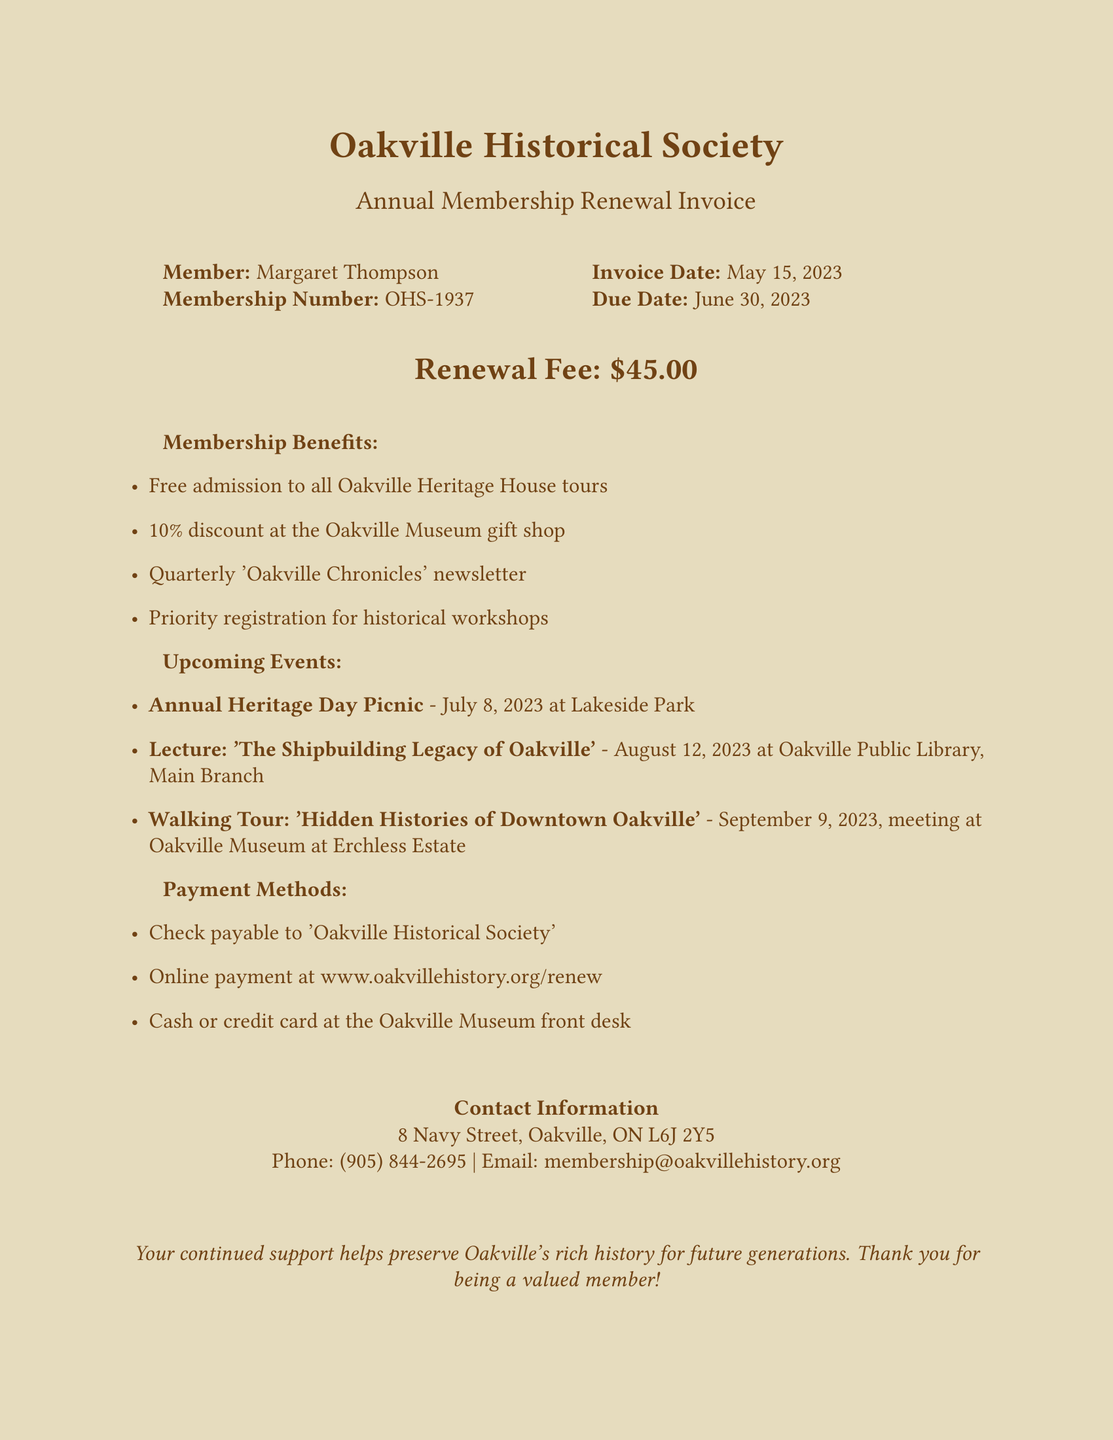What is the membership number? The membership number is provided in the document, specifically for Margaret Thompson.
Answer: OHS-1937 When is the invoice due? The due date for the invoice is clearly stated in the document.
Answer: June 30, 2023 What is the renewal fee amount? The renewal fee is mentioned in a prominent position in the document.
Answer: $45.00 What discount do members receive at the gift shop? The document lists the benefits of membership, including shop discounts.
Answer: 10% What is the date for the Annual Heritage Day Picnic? The upcoming events include a specific date for the Annual Heritage Day Picnic.
Answer: July 8, 2023 What is the meeting location for the Walking Tour? The document specifies where the Walking Tour will meet.
Answer: Oakville Museum at Erchless Estate How can members pay their renewal fee online? Payment methods are listed in the document, including online payment details.
Answer: www.oakvillehistory.org/renew What type of newsletter do members receive? The membership benefits include a specific type of newsletter.
Answer: 'Oakville Chronicles' What is one of the upcoming lectures about? The document lists an upcoming lecture and its topic.
Answer: 'The Shipbuilding Legacy of Oakville' 